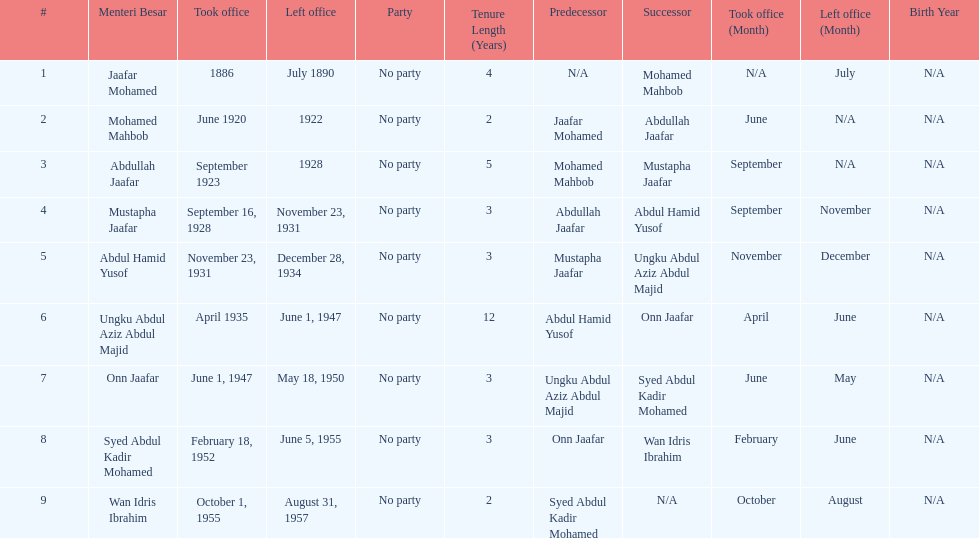How long did ungku abdul aziz abdul majid serve? 12 years. 